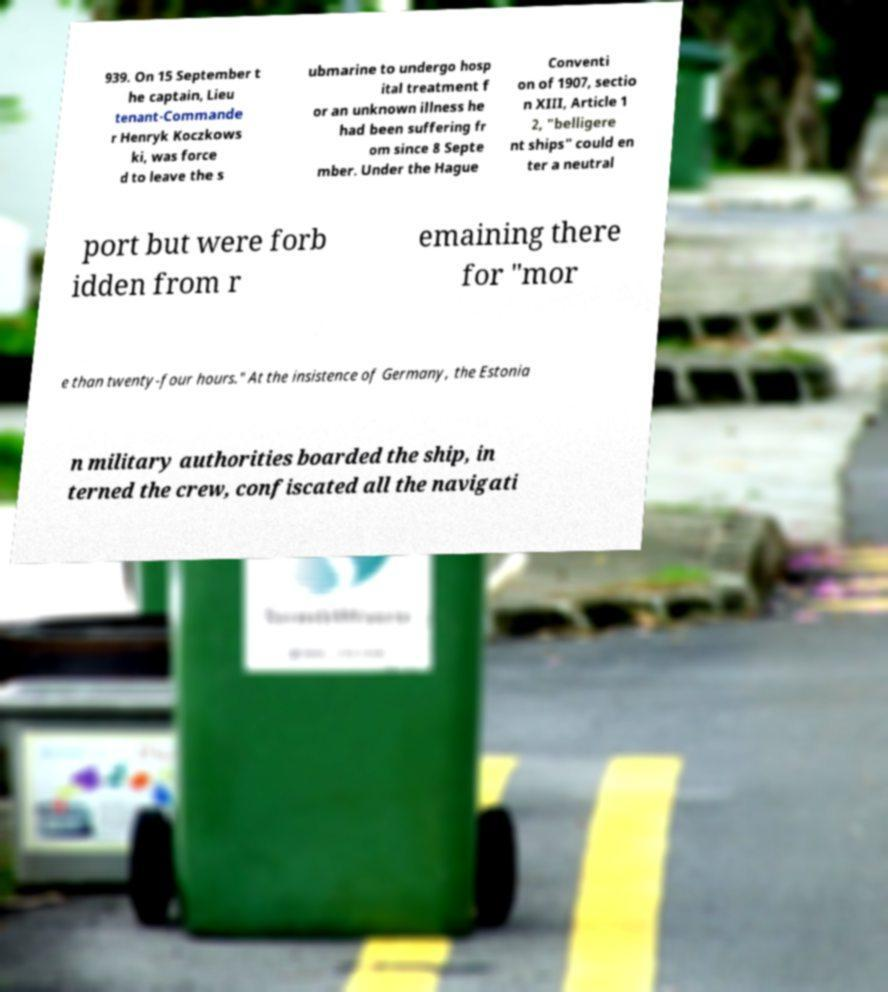Please identify and transcribe the text found in this image. 939. On 15 September t he captain, Lieu tenant-Commande r Henryk Koczkows ki, was force d to leave the s ubmarine to undergo hosp ital treatment f or an unknown illness he had been suffering fr om since 8 Septe mber. Under the Hague Conventi on of 1907, sectio n XIII, Article 1 2, "belligere nt ships" could en ter a neutral port but were forb idden from r emaining there for "mor e than twenty-four hours." At the insistence of Germany, the Estonia n military authorities boarded the ship, in terned the crew, confiscated all the navigati 